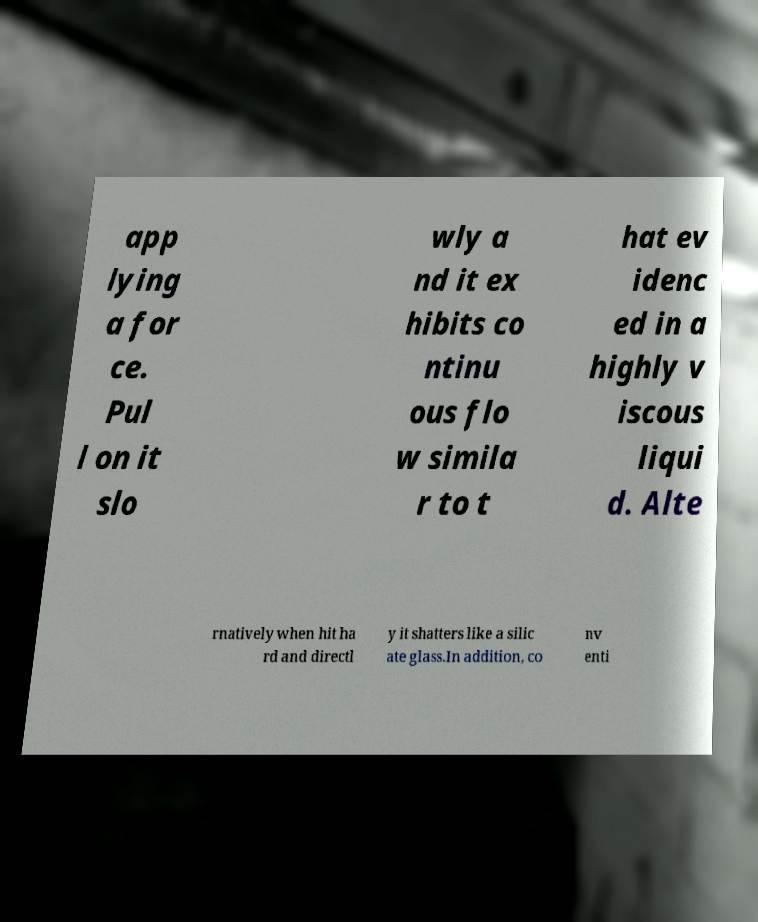What messages or text are displayed in this image? I need them in a readable, typed format. app lying a for ce. Pul l on it slo wly a nd it ex hibits co ntinu ous flo w simila r to t hat ev idenc ed in a highly v iscous liqui d. Alte rnatively when hit ha rd and directl y it shatters like a silic ate glass.In addition, co nv enti 